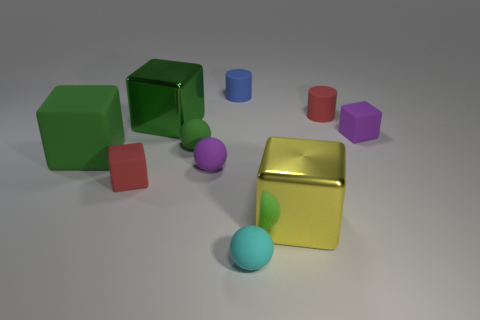Subtract all green spheres. How many spheres are left? 2 Subtract all gray cylinders. How many green cubes are left? 2 Subtract 2 cubes. How many cubes are left? 3 Subtract all yellow blocks. How many blocks are left? 4 Subtract all gray spheres. Subtract all brown cubes. How many spheres are left? 3 Subtract all cylinders. How many objects are left? 8 Subtract all large yellow things. Subtract all rubber cylinders. How many objects are left? 7 Add 4 tiny red cylinders. How many tiny red cylinders are left? 5 Add 4 big yellow rubber objects. How many big yellow rubber objects exist? 4 Subtract 0 gray blocks. How many objects are left? 10 